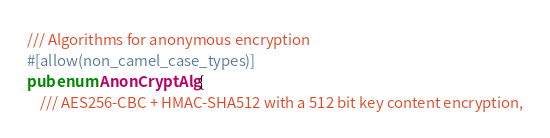<code> <loc_0><loc_0><loc_500><loc_500><_Rust_>/// Algorithms for anonymous encryption
#[allow(non_camel_case_types)]
pub enum AnonCryptAlg {
    /// AES256-CBC + HMAC-SHA512 with a 512 bit key content encryption,</code> 